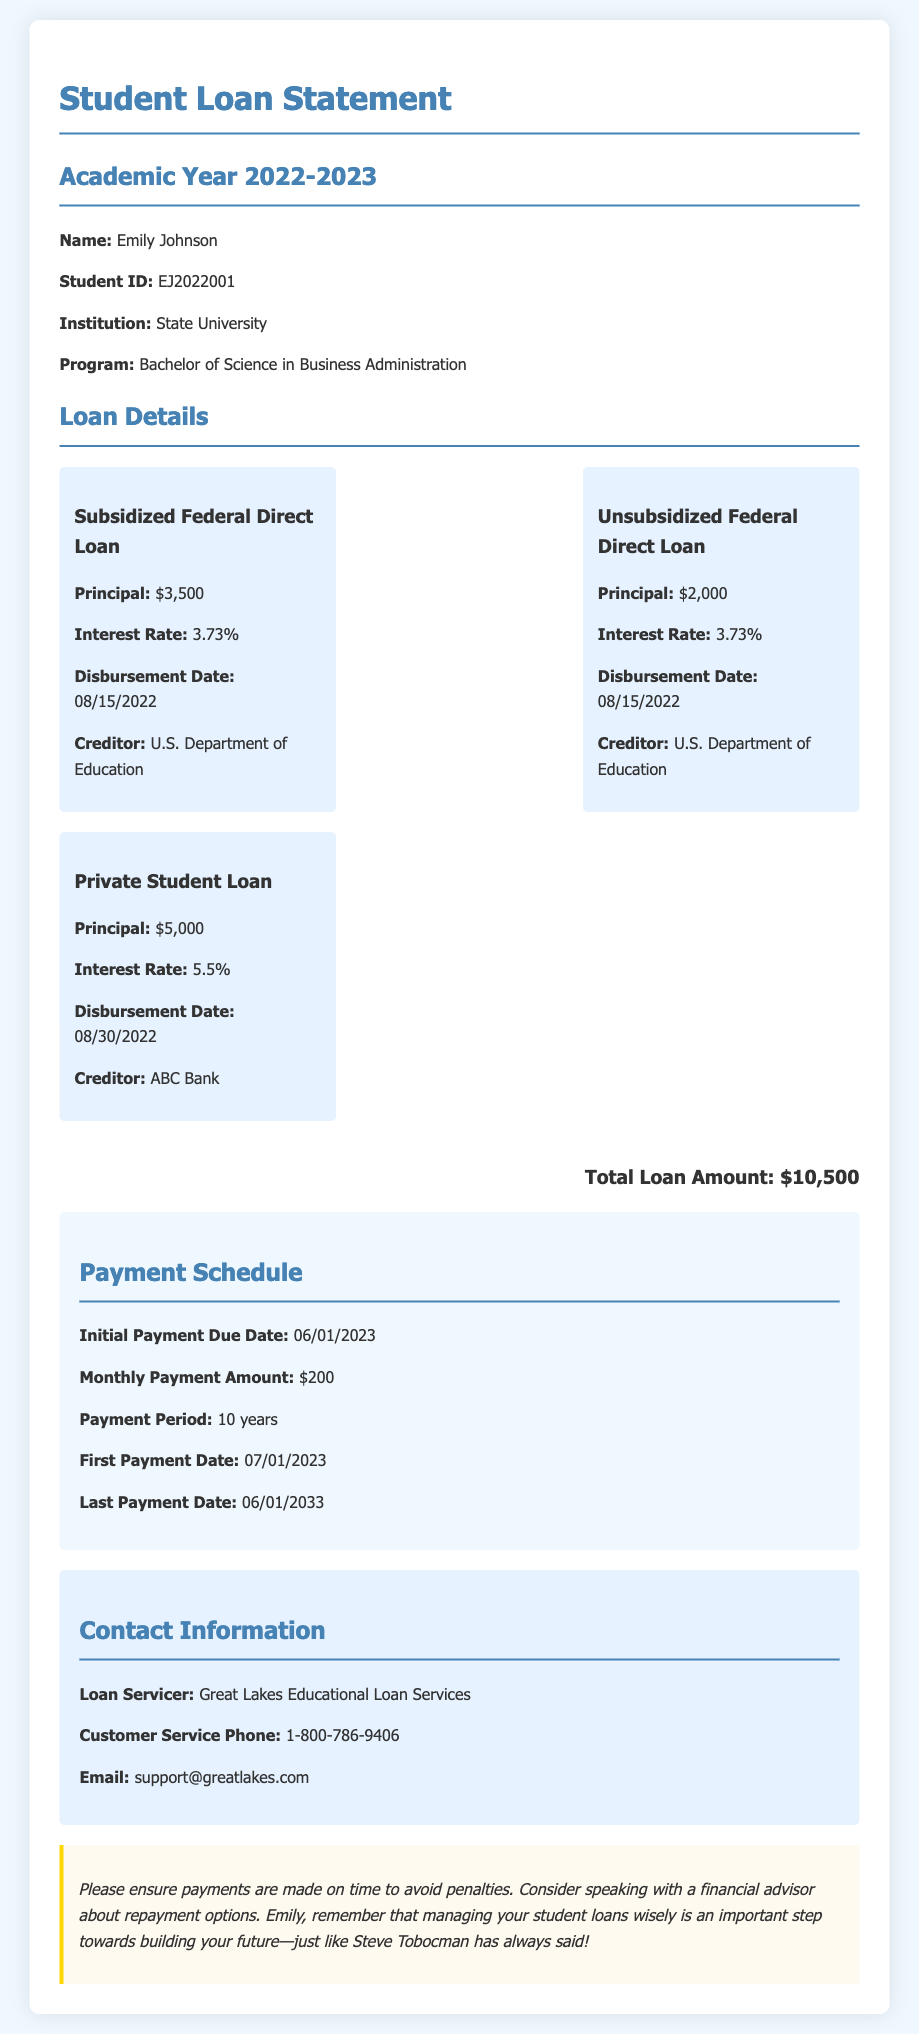What is the total loan amount? The total loan amount is displayed prominently in the document, which sums the individual loan principal amounts.
Answer: $10,500 What is the interest rate for the Unsubsidized Federal Direct Loan? The interest rate is specified for each loan type within the loan details section.
Answer: 3.73% When is the first payment due? The first payment due date is indicated in the payment schedule section of the document.
Answer: 06/01/2023 Who is the creditor for the Private Student Loan? The creditor is listed under each loan type in the loan details section.
Answer: ABC Bank What is the monthly payment amount? The monthly payment amount is provided in the payment schedule.
Answer: $200 What is the disbursement date for the Subsidized Federal Direct Loan? The disbursement date can be found next to the loan details for each type of loan.
Answer: 08/15/2022 How long is the payment period for the loans? The payment period duration is specified in the payment schedule section.
Answer: 10 years When will the last payment be made? The last payment date is mentioned in the payment schedule, giving clear timelines for repayment.
Answer: 06/01/2033 What should Emily consider according to the notes? The notes section provides reminders related to managing loans effectively.
Answer: Speaking with a financial advisor about repayment options 